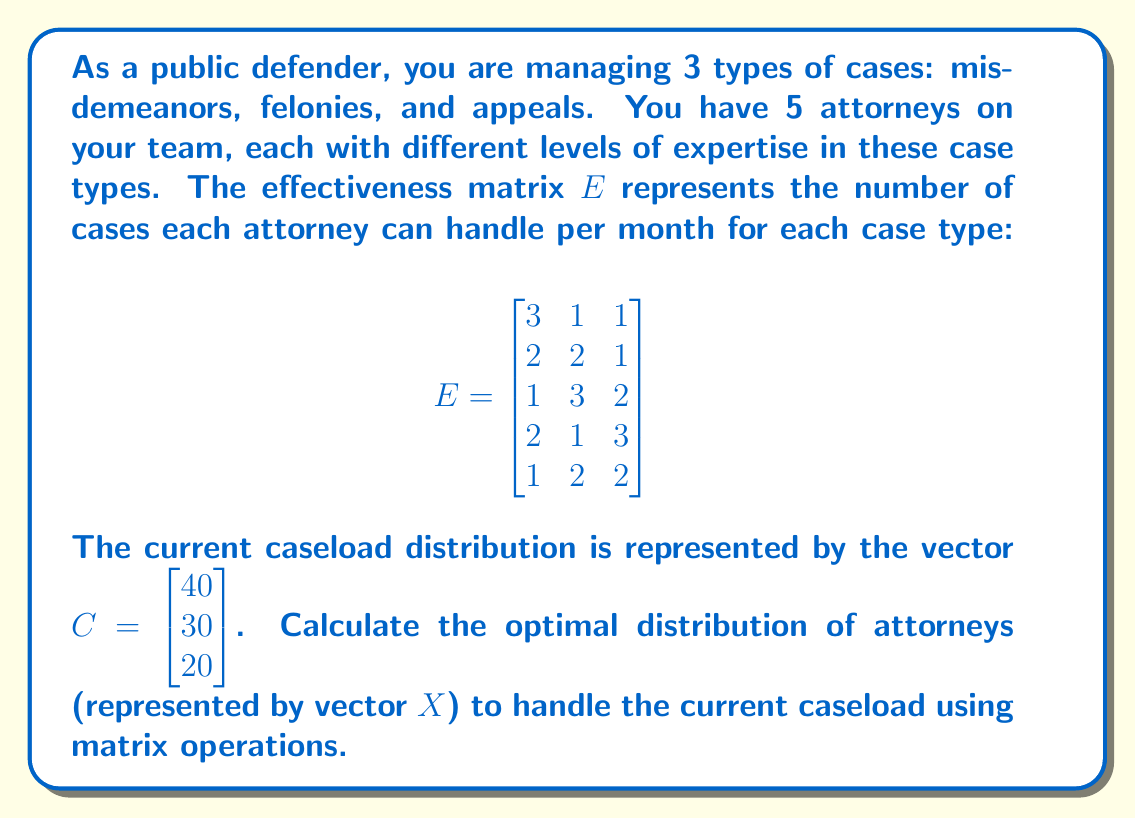Provide a solution to this math problem. To solve this problem, we need to find the vector $X$ that satisfies the equation $EX = C$, where $E$ is the effectiveness matrix and $C$ is the current caseload vector.

Step 1: Set up the matrix equation
$$\begin{bmatrix}
3 & 1 & 1 \\
2 & 2 & 1 \\
1 & 3 & 2 \\
2 & 1 & 3 \\
1 & 2 & 2
\end{bmatrix} \begin{bmatrix} x_1 \\ x_2 \\ x_3 \\ x_4 \\ x_5 \end{bmatrix} = \begin{bmatrix} 40 \\ 30 \\ 20 \end{bmatrix}$$

Step 2: To solve this system, we need to use the pseudoinverse (Moore-Penrose inverse) of matrix $E$, denoted as $E^+$, because $E$ is not a square matrix.

Step 3: Calculate $E^+$ (this step would typically be done using a computer or calculator)
$$E^+ \approx \begin{bmatrix}
0.2368 & 0.1447 & -0.0263 \\
-0.0658 & 0.1711 & 0.1974 \\
-0.0658 & -0.0395 & 0.3289 \\
0.1053 & -0.1184 & 0.2368 \\
-0.0658 & 0.0658 & 0.1316
\end{bmatrix}$$

Step 4: Multiply $E^+$ by $C$ to get $X$
$$X = E^+C = \begin{bmatrix}
0.2368 & 0.1447 & -0.0263 \\
-0.0658 & 0.1711 & 0.1974 \\
-0.0658 & -0.0395 & 0.3289 \\
0.1053 & -0.1184 & 0.2368 \\
-0.0658 & 0.0658 & 0.1316
\end{bmatrix} \begin{bmatrix} 40 \\ 30 \\ 20 \end{bmatrix}$$

Step 5: Perform the matrix multiplication
$$X \approx \begin{bmatrix} 12.11 \\ 7.89 \\ 4.74 \\ 5.26 \\ 5.00 \end{bmatrix}$$

Step 6: Interpret the results
The components of $X$ represent the optimal number of hours each attorney should dedicate to cases per day, assuming an 8-hour workday. For example, the first attorney should spend approximately 12.11 hours per day on cases, which is not feasible. We need to normalize these values to fit within an 8-hour workday.

Step 7: Normalize the results
Total hours: $12.11 + 7.89 + 4.74 + 5.26 + 5.00 = 35$
Normalization factor: $8 / (35/5) = 1.14$

Multiply each component by 1.14 to get the final distribution:
$$X_{final} \approx \begin{bmatrix} 13.81 \\ 9.00 \\ 5.40 \\ 6.00 \\ 5.70 \end{bmatrix}$$
Answer: $X_{final} \approx [13.81, 9.00, 5.40, 6.00, 5.70]$ hours per week 